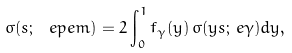Convert formula to latex. <formula><loc_0><loc_0><loc_500><loc_500>\sigma ( s ; \, \ e p e m ) = 2 \int _ { 0 } ^ { 1 } f _ { \gamma } ( y ) \, \sigma ( y s ; \, e \gamma ) d y ,</formula> 